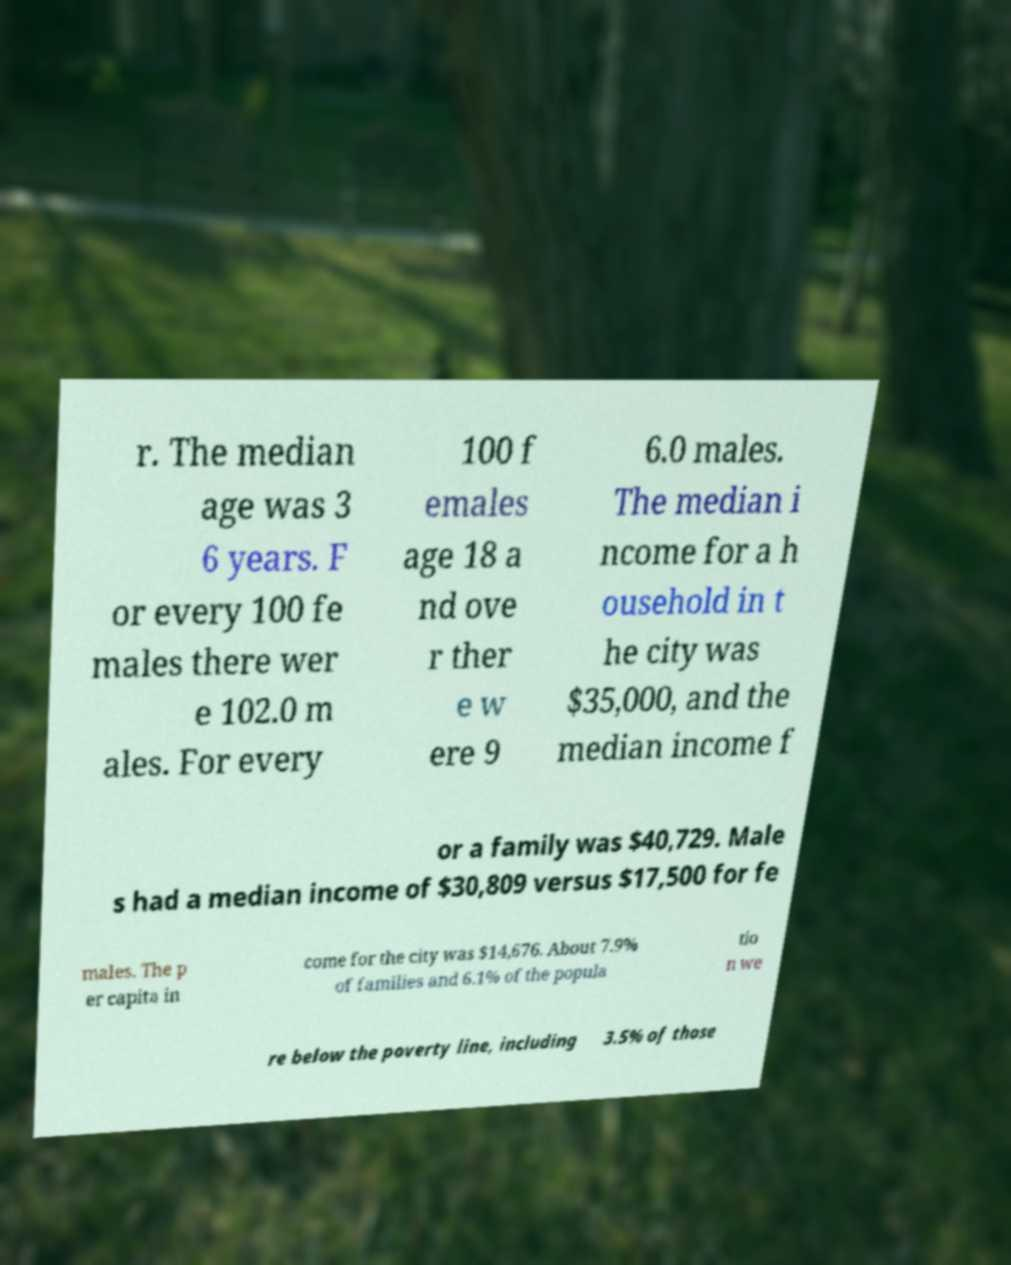Can you read and provide the text displayed in the image?This photo seems to have some interesting text. Can you extract and type it out for me? r. The median age was 3 6 years. F or every 100 fe males there wer e 102.0 m ales. For every 100 f emales age 18 a nd ove r ther e w ere 9 6.0 males. The median i ncome for a h ousehold in t he city was $35,000, and the median income f or a family was $40,729. Male s had a median income of $30,809 versus $17,500 for fe males. The p er capita in come for the city was $14,676. About 7.9% of families and 6.1% of the popula tio n we re below the poverty line, including 3.5% of those 